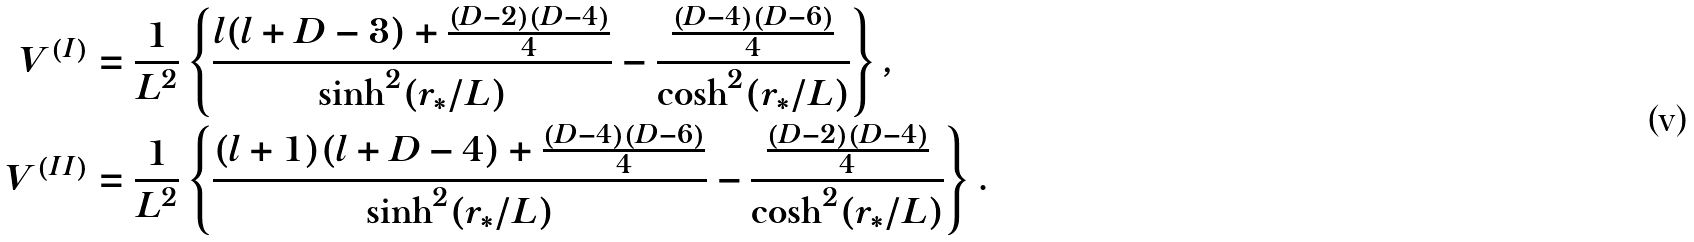<formula> <loc_0><loc_0><loc_500><loc_500>V ^ { ( I ) } & = \frac { 1 } { L ^ { 2 } } \left \{ \frac { l ( l + D - 3 ) + \frac { ( D - 2 ) ( D - 4 ) } { 4 } } { \sinh ^ { 2 } ( r _ { * } / L ) } - \frac { \frac { ( D - 4 ) ( D - 6 ) } { 4 } } { \cosh ^ { 2 } ( r _ { * } / L ) } \right \} , \\ V ^ { ( I I ) } & = \frac { 1 } { L ^ { 2 } } \left \{ \frac { ( l + 1 ) ( l + D - 4 ) + \frac { ( D - 4 ) ( D - 6 ) } { 4 } } { \sinh ^ { 2 } ( r _ { * } / L ) } - \frac { \frac { ( D - 2 ) ( D - 4 ) } { 4 } } { \cosh ^ { 2 } ( r _ { * } / L ) } \right \} .</formula> 